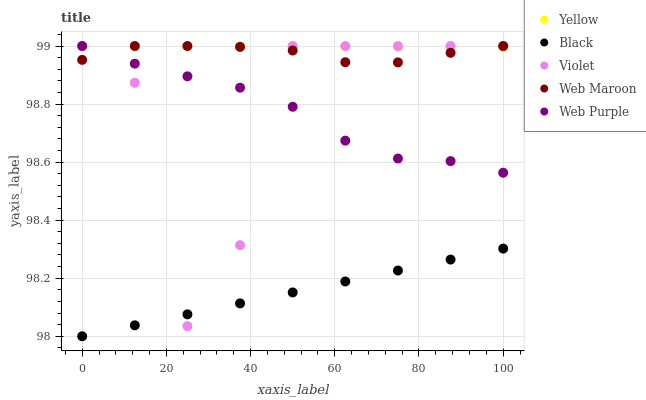Does Black have the minimum area under the curve?
Answer yes or no. Yes. Does Yellow have the maximum area under the curve?
Answer yes or no. Yes. Does Web Purple have the minimum area under the curve?
Answer yes or no. No. Does Web Purple have the maximum area under the curve?
Answer yes or no. No. Is Yellow the smoothest?
Answer yes or no. Yes. Is Violet the roughest?
Answer yes or no. Yes. Is Web Purple the smoothest?
Answer yes or no. No. Is Web Purple the roughest?
Answer yes or no. No. Does Black have the lowest value?
Answer yes or no. Yes. Does Web Purple have the lowest value?
Answer yes or no. No. Does Violet have the highest value?
Answer yes or no. Yes. Does Black have the highest value?
Answer yes or no. No. Is Black less than Yellow?
Answer yes or no. Yes. Is Web Purple greater than Black?
Answer yes or no. Yes. Does Violet intersect Black?
Answer yes or no. Yes. Is Violet less than Black?
Answer yes or no. No. Is Violet greater than Black?
Answer yes or no. No. Does Black intersect Yellow?
Answer yes or no. No. 